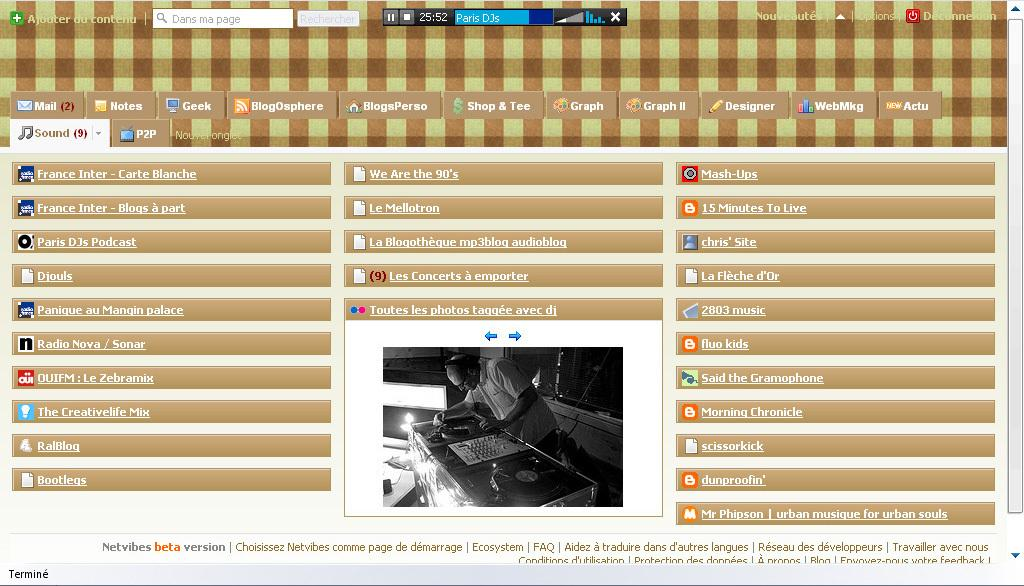What type of image is being described? The image is a screenshot of a screen. What type of jam is being spread on the crow during the holiday in the image? There is no jam, crow, or holiday present in the image, as it is a screenshot of a screen. 